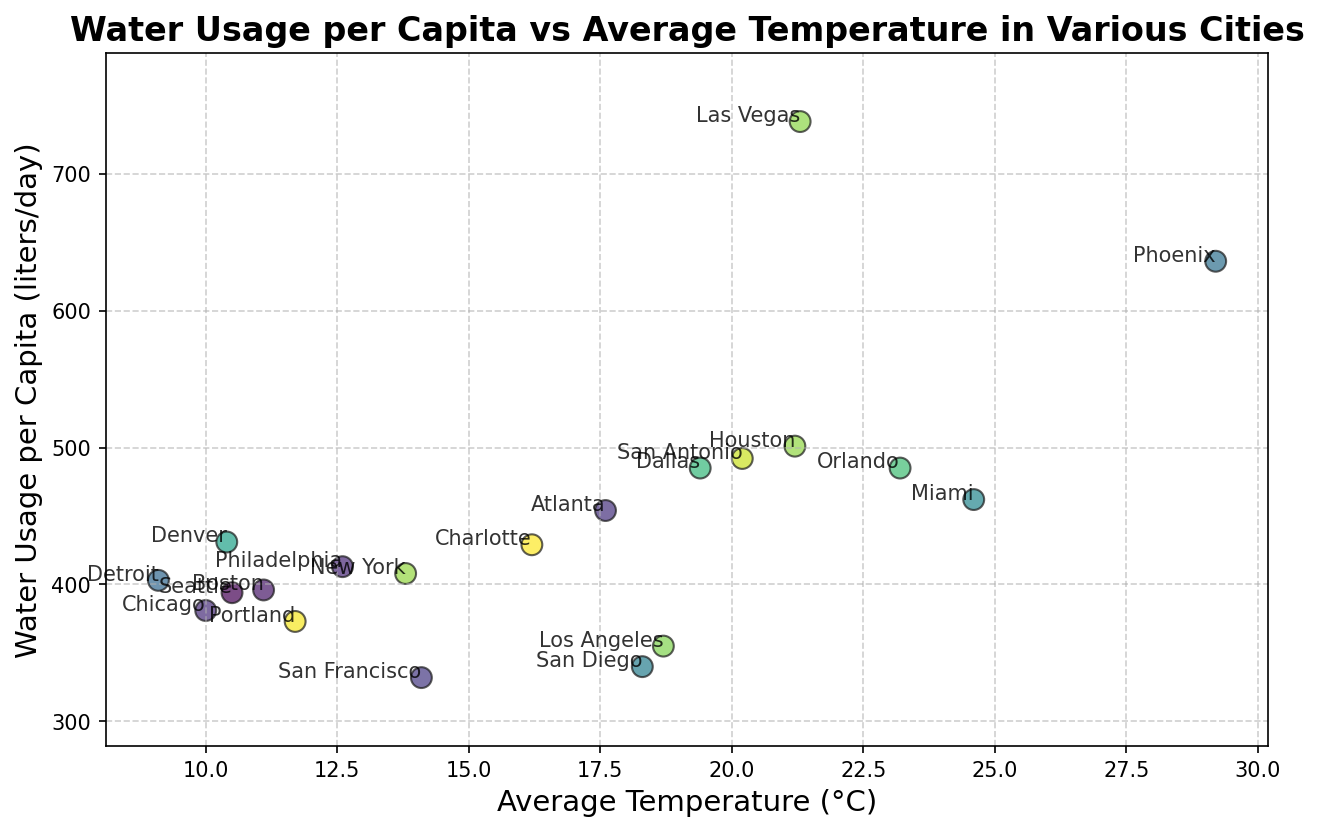Which city has the highest water usage per capita? By looking at the scatter plot, identify the city with the highest y-value on the plot, which represents water usage per capita.
Answer: Las Vegas Which city has the lowest water usage per capita? By looking at the scatter plot, identify the city with the lowest y-value on the plot.
Answer: San Francisco Is there a correlation between average temperature and water usage per capita? Observe the overall trend of the data points in the scatter plot. If water usage tends to increase with temperature, a positive correlation exists; otherwise, it is different or none.
Answer: Yes, there is a positive correlation Among cities with an average temperature below 15°C, which one has the highest water usage per capita? Focus on data points with x-values (average temperature) below 15°C and then identify the one with the highest y-value (water usage).
Answer: New York How does the water usage in Phoenix compare to that in San Francisco? Identify the positions of Phoenix and San Francisco on the scatter plot. Phoenix will have a higher y-value compared to San Francisco.
Answer: Phoenix has higher water usage than San Francisco What is the difference in water usage per capita between New York and Chicago? Locate the data points for New York and Chicago on the plot. Subtract the water usage value of Chicago from that of New York.
Answer: 27 liters/day Which cities have a similar average temperature but different water usage per capita? Look for cities with nearly the same x-values but different y-values. Compare and identify such city pairs.
Answer: Los Angeles and San Diego How many cities have an average temperature between 10°C and 20°C? Count the data points whose x-values (average temperature) fall within the 10°C to 20°C range.
Answer: 11 cities What is the range of water usage per capita values in the plot? Determine the minimum and maximum y-values in the plot and calculate their difference.
Answer: 406 liters/day (738 - 332) Which city has the highest water usage per capita among those with an average temperature above 20°C? Identify cities with x-values above 20°C and then find the one with the highest y-value.
Answer: Las Vegas 